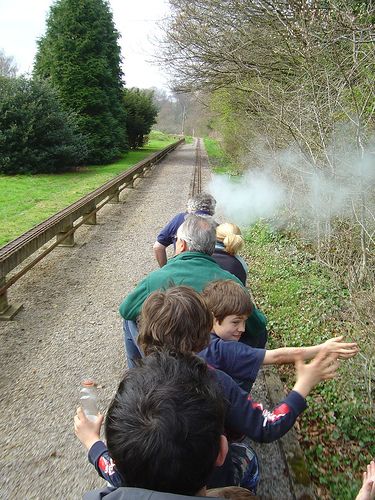<image>
Is there a smoke in the air? Yes. The smoke is contained within or inside the air, showing a containment relationship. Is there a boy on the grass? No. The boy is not positioned on the grass. They may be near each other, but the boy is not supported by or resting on top of the grass. 